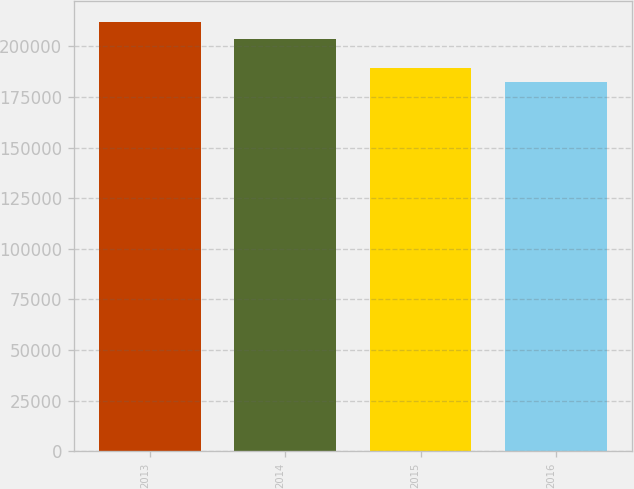<chart> <loc_0><loc_0><loc_500><loc_500><bar_chart><fcel>2013<fcel>2014<fcel>2015<fcel>2016<nl><fcel>211770<fcel>203439<fcel>189129<fcel>182149<nl></chart> 